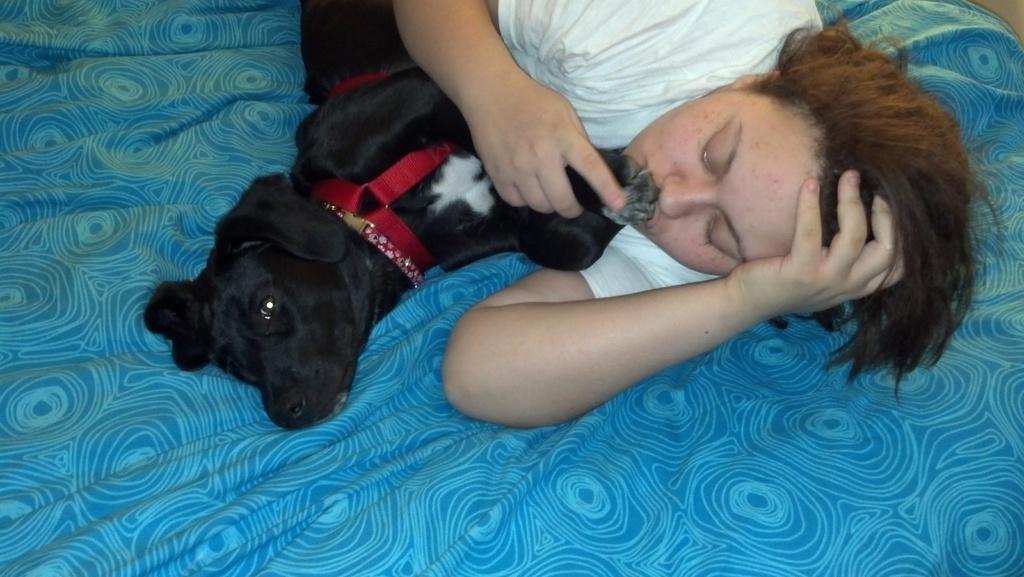Can you describe this image briefly? In this image there is person lying and holding the dog. There is a black dog lying beside the woman. 